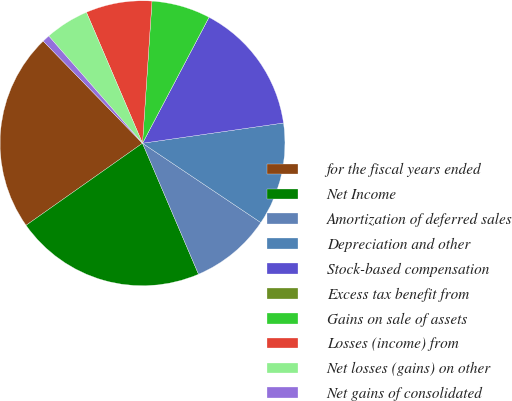<chart> <loc_0><loc_0><loc_500><loc_500><pie_chart><fcel>for the fiscal years ended<fcel>Net Income<fcel>Amortization of deferred sales<fcel>Depreciation and other<fcel>Stock-based compensation<fcel>Excess tax benefit from<fcel>Gains on sale of assets<fcel>Losses (income) from<fcel>Net losses (gains) on other<fcel>Net gains of consolidated<nl><fcel>22.5%<fcel>21.66%<fcel>9.17%<fcel>11.67%<fcel>15.0%<fcel>0.0%<fcel>6.67%<fcel>7.5%<fcel>5.0%<fcel>0.84%<nl></chart> 